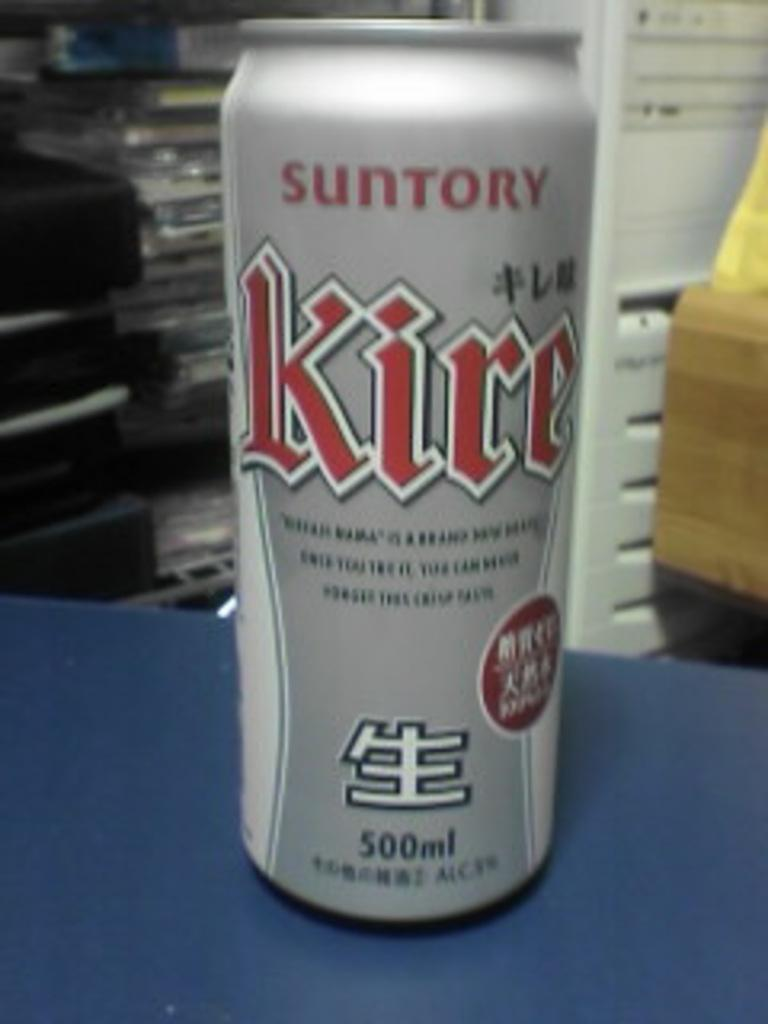<image>
Create a compact narrative representing the image presented. A canned beverage by Suntory has a volume of 500 mL. 